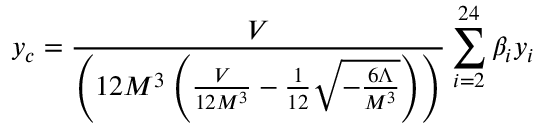Convert formula to latex. <formula><loc_0><loc_0><loc_500><loc_500>y _ { c } = \frac { V } { \left ( 1 2 M ^ { 3 } \left ( \frac { V } { 1 2 M ^ { 3 } } - \frac { 1 } { 1 2 } \sqrt { - \frac { 6 \Lambda } { M ^ { 3 } } } \right ) \right ) } \sum _ { i = 2 } ^ { 2 4 } \beta _ { i } y _ { i }</formula> 